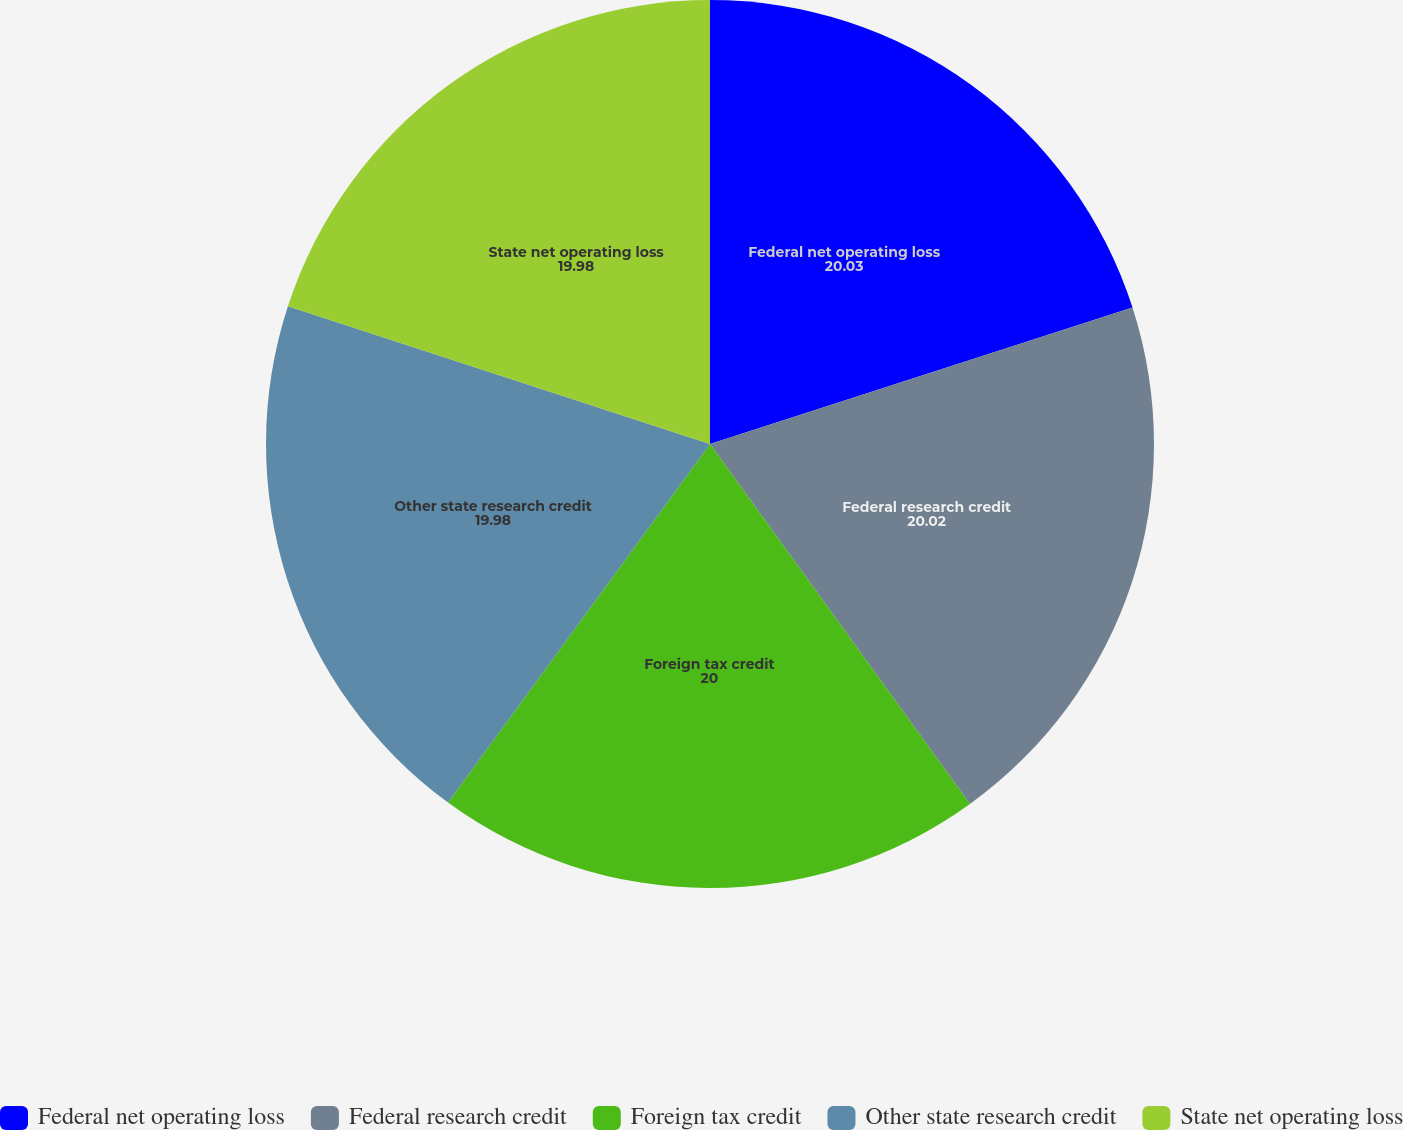Convert chart. <chart><loc_0><loc_0><loc_500><loc_500><pie_chart><fcel>Federal net operating loss<fcel>Federal research credit<fcel>Foreign tax credit<fcel>Other state research credit<fcel>State net operating loss<nl><fcel>20.03%<fcel>20.02%<fcel>20.0%<fcel>19.98%<fcel>19.98%<nl></chart> 